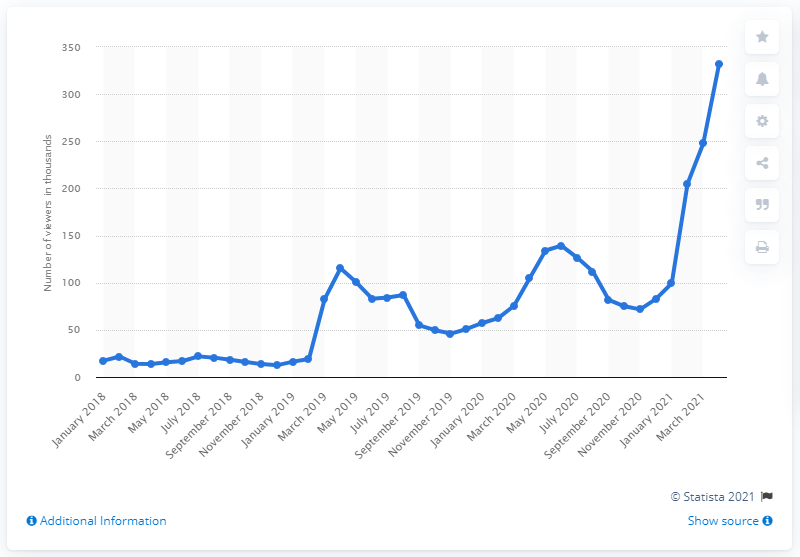Outline some significant characteristics in this image. Twitch began showing Grand Theft Auto V events in April 2021. 